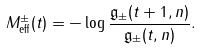Convert formula to latex. <formula><loc_0><loc_0><loc_500><loc_500>M ^ { \pm } _ { \text {eff} } ( t ) = - \log \frac { \mathfrak { g } _ { \pm } ( t + 1 , n ) } { \mathfrak { g } _ { \pm } ( t , n ) } .</formula> 